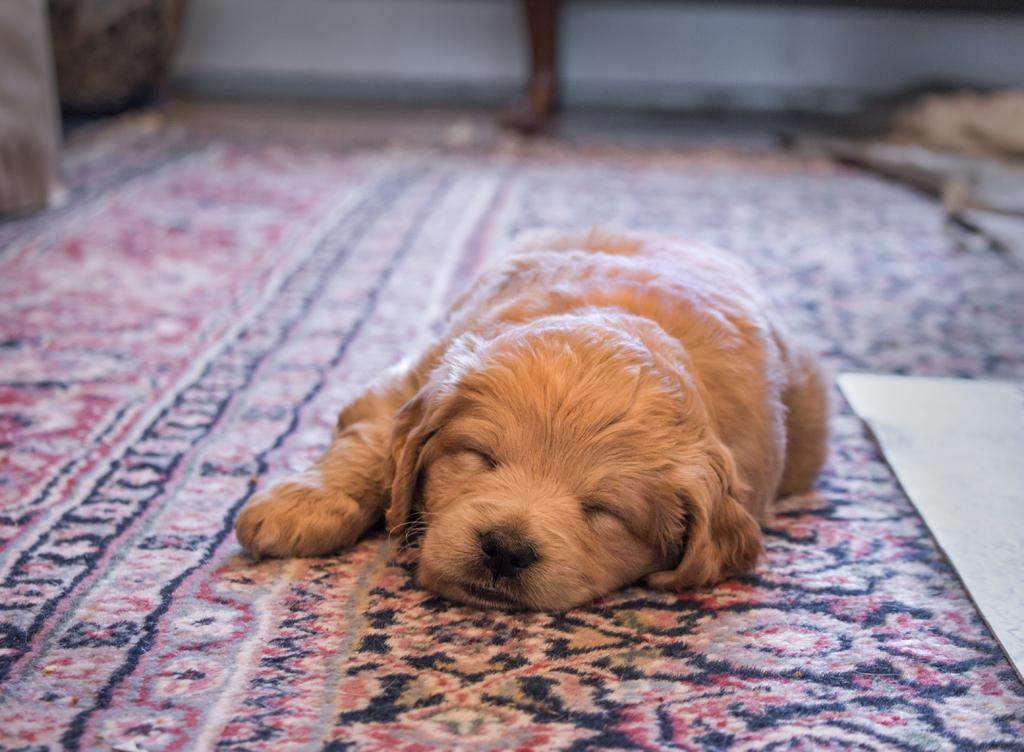What type of animal can be seen in the image? There is a dog in the image. What is the dog doing in the image? The dog is sleeping on a floor mat. What can be seen in the background of the image? There are other objects visible in the background, and there is a wall in the background. What type of lunch is the dog eating in the image? There is no lunch present in the image; the dog is sleeping on a floor mat. What color are the cherries on the dog's bed in the image? There are no cherries present in the image, and the dog is sleeping on a floor mat, not a bed. 